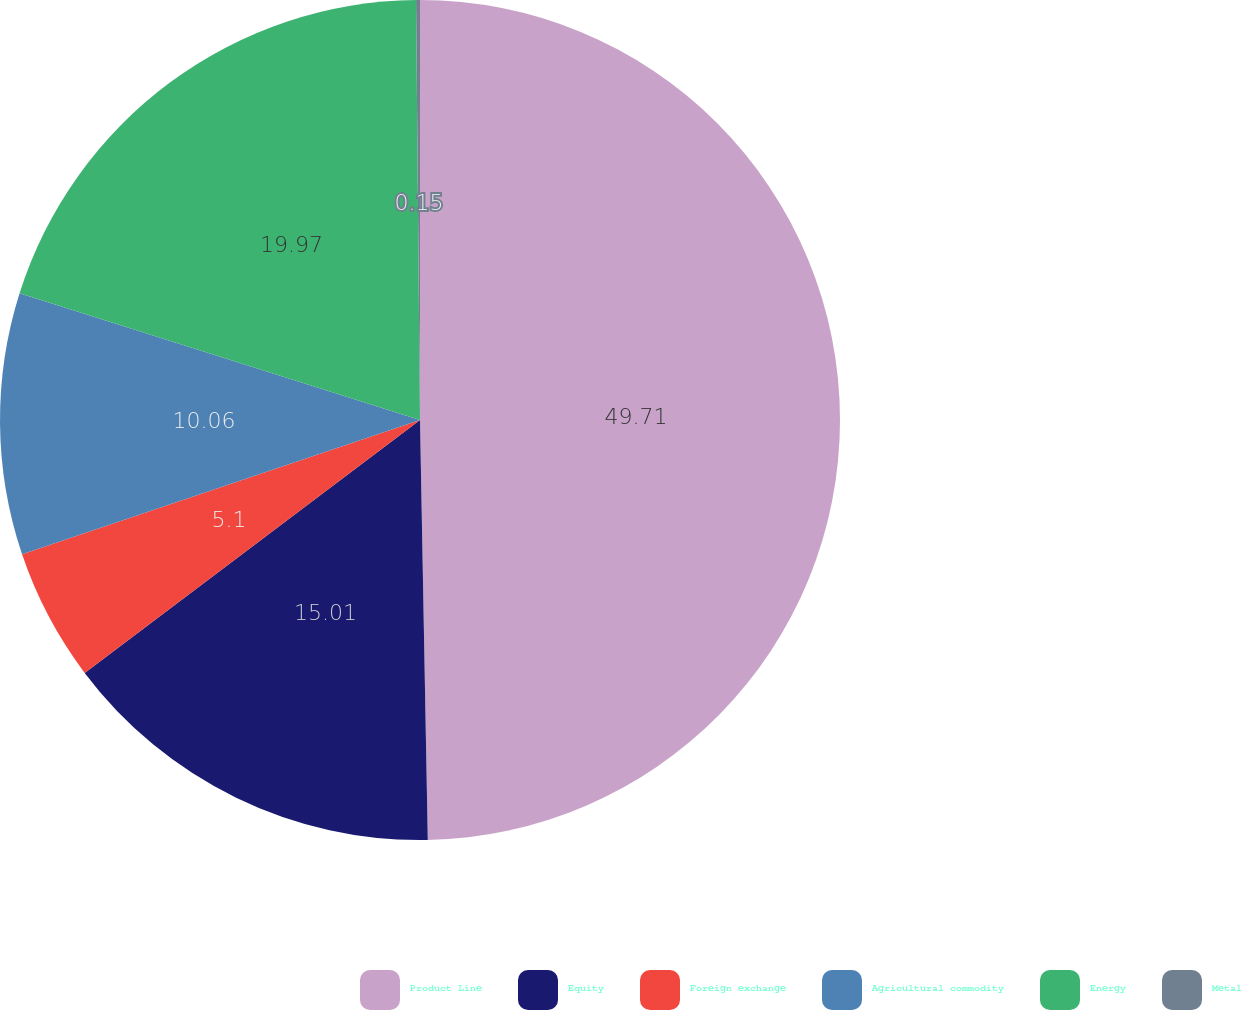Convert chart. <chart><loc_0><loc_0><loc_500><loc_500><pie_chart><fcel>Product Line<fcel>Equity<fcel>Foreign exchange<fcel>Agricultural commodity<fcel>Energy<fcel>Metal<nl><fcel>49.7%<fcel>15.01%<fcel>5.1%<fcel>10.06%<fcel>19.97%<fcel>0.15%<nl></chart> 